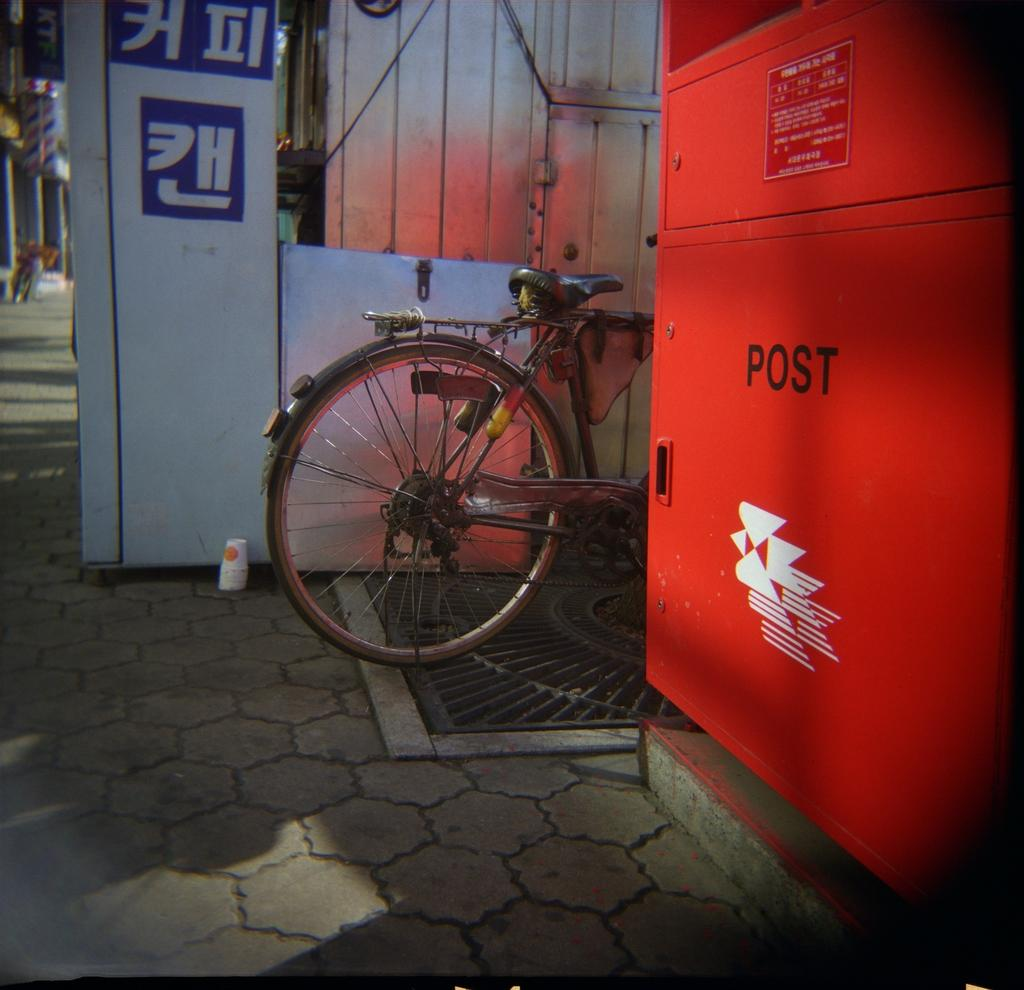What object is the main focus of the image? There is a post box in the image. What is located behind the post box? There is a cycle behind the post box. What can be seen behind the cycle? There appears to be a store behind the cycle. What type of prose is being recited by the group in the image? There is no group or prose present in the image; it only features a post box, a cycle, and a store. 